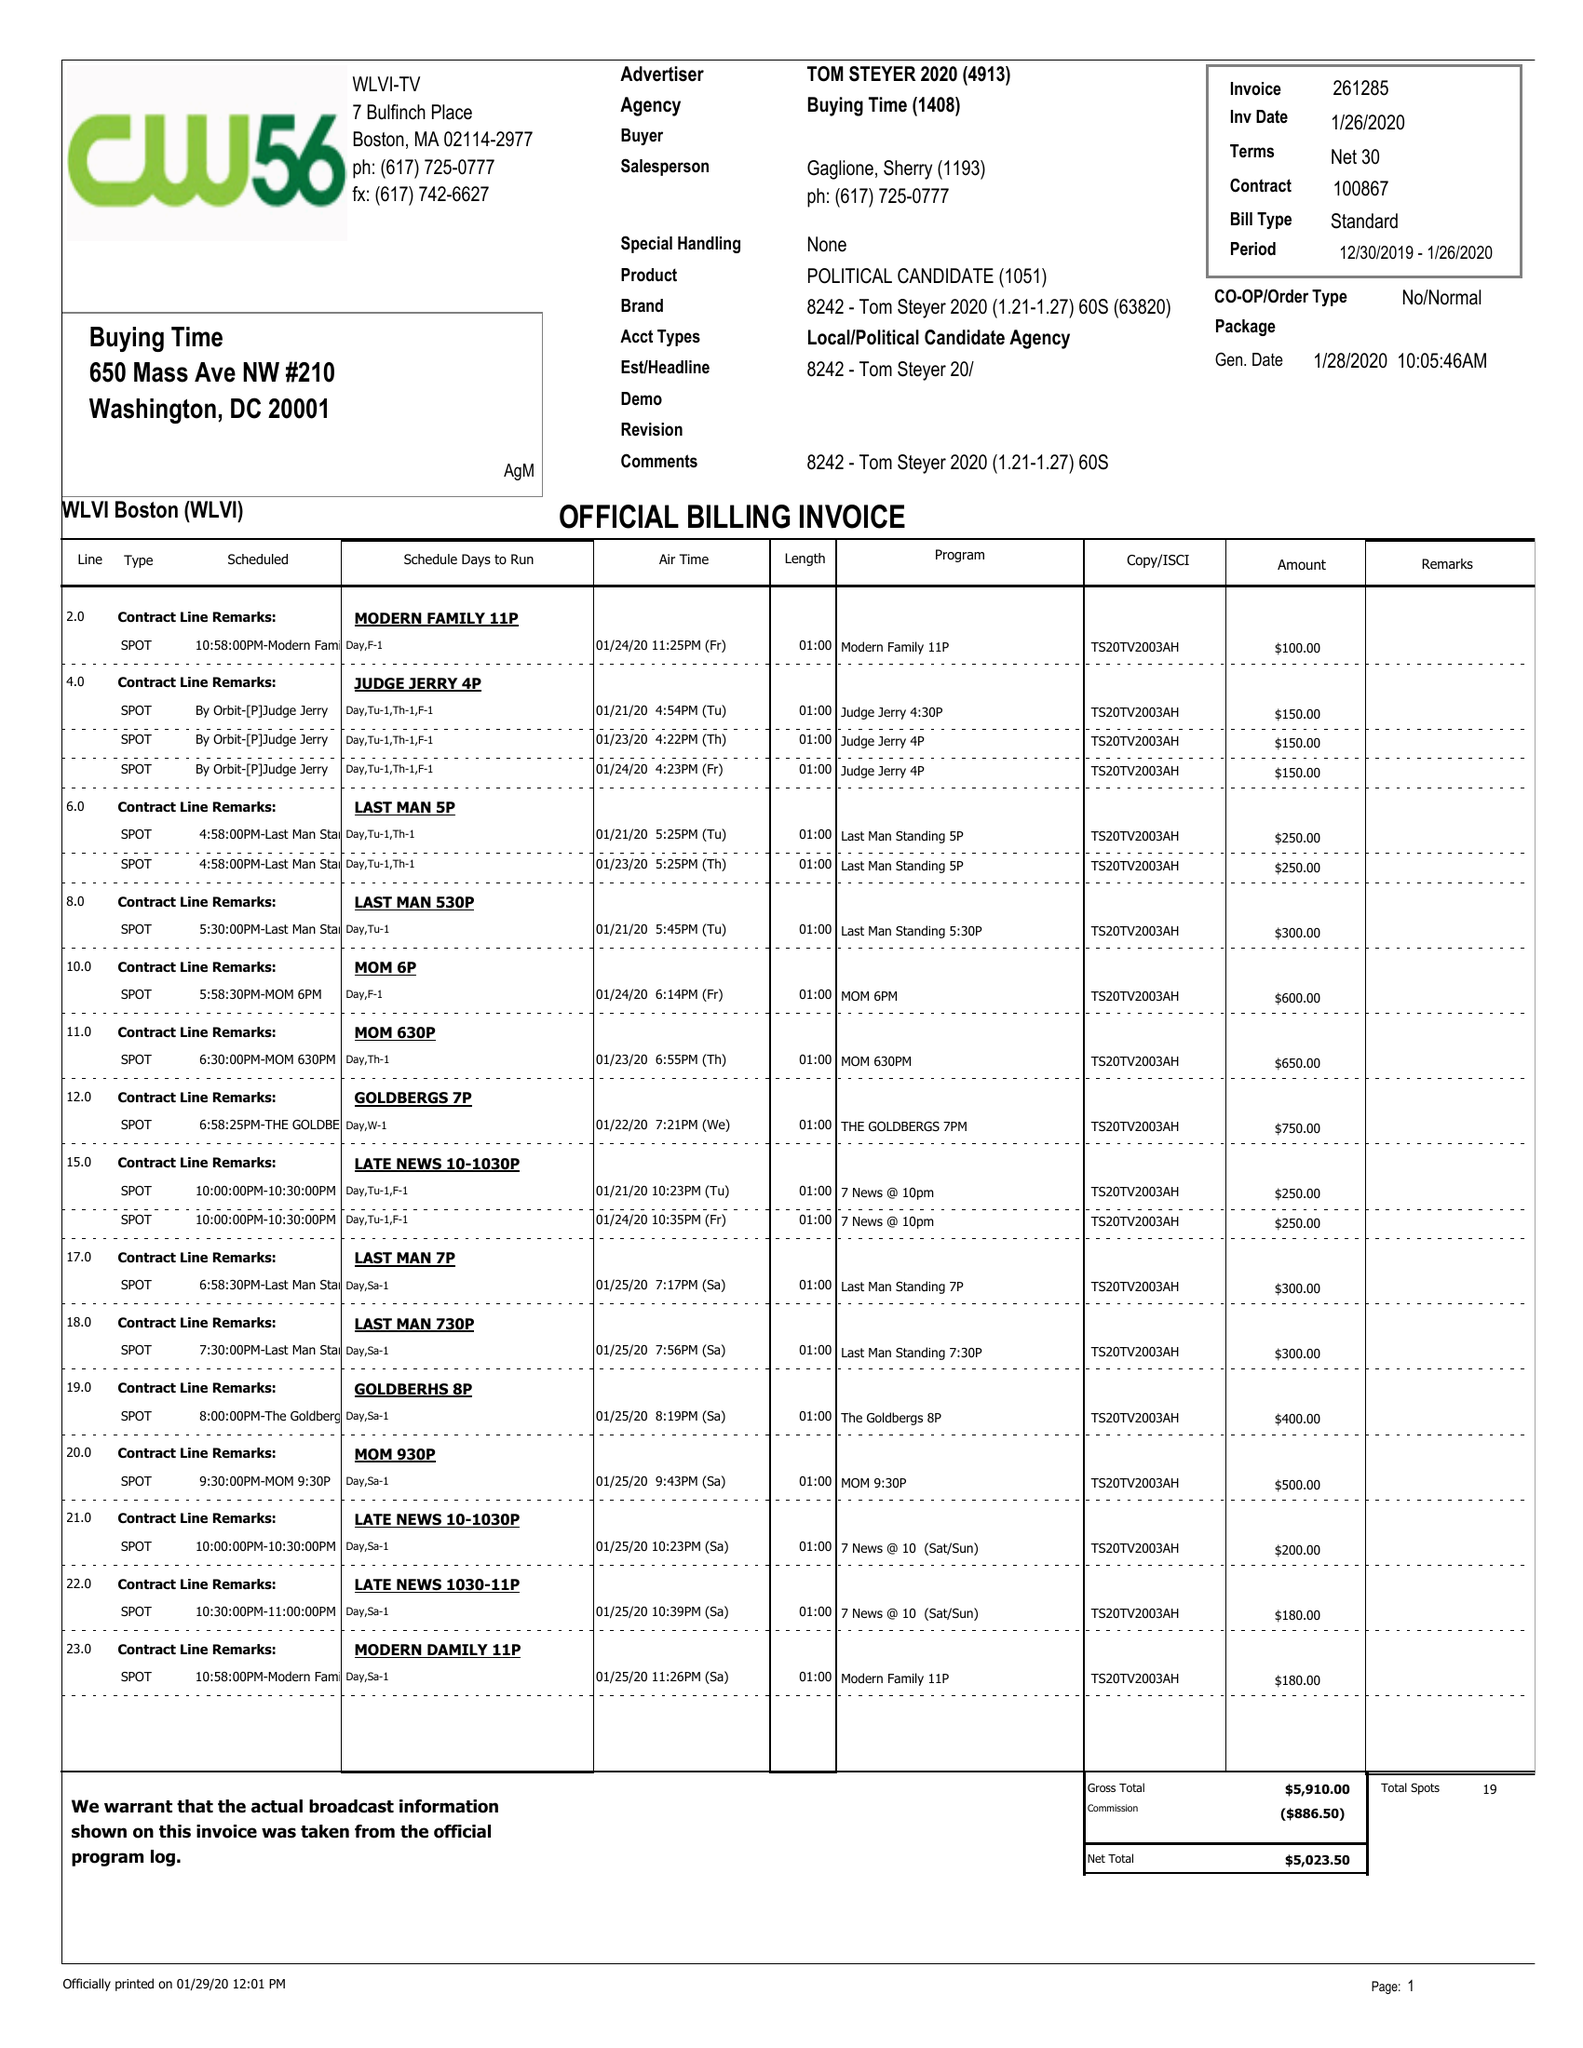What is the value for the flight_from?
Answer the question using a single word or phrase. 12/30/19 